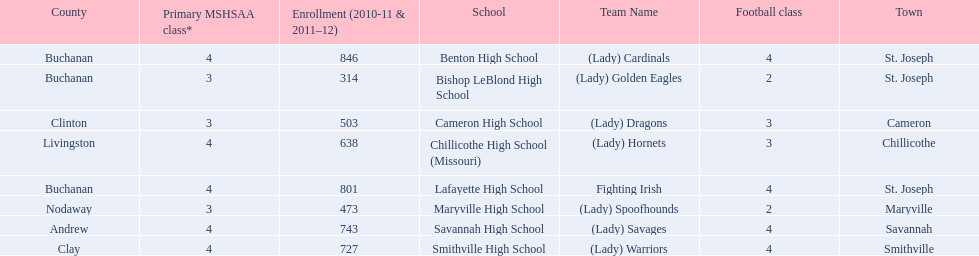How many of the schools had at least 500 students enrolled in the 2010-2011 and 2011-2012 season? 6. I'm looking to parse the entire table for insights. Could you assist me with that? {'header': ['County', 'Primary MSHSAA class*', 'Enrollment (2010-11 & 2011–12)', 'School', 'Team Name', 'Football class', 'Town'], 'rows': [['Buchanan', '4', '846', 'Benton High School', '(Lady) Cardinals', '4', 'St. Joseph'], ['Buchanan', '3', '314', 'Bishop LeBlond High School', '(Lady) Golden Eagles', '2', 'St. Joseph'], ['Clinton', '3', '503', 'Cameron High School', '(Lady) Dragons', '3', 'Cameron'], ['Livingston', '4', '638', 'Chillicothe High School (Missouri)', '(Lady) Hornets', '3', 'Chillicothe'], ['Buchanan', '4', '801', 'Lafayette High School', 'Fighting Irish', '4', 'St. Joseph'], ['Nodaway', '3', '473', 'Maryville High School', '(Lady) Spoofhounds', '2', 'Maryville'], ['Andrew', '4', '743', 'Savannah High School', '(Lady) Savages', '4', 'Savannah'], ['Clay', '4', '727', 'Smithville High School', '(Lady) Warriors', '4', 'Smithville']]} 